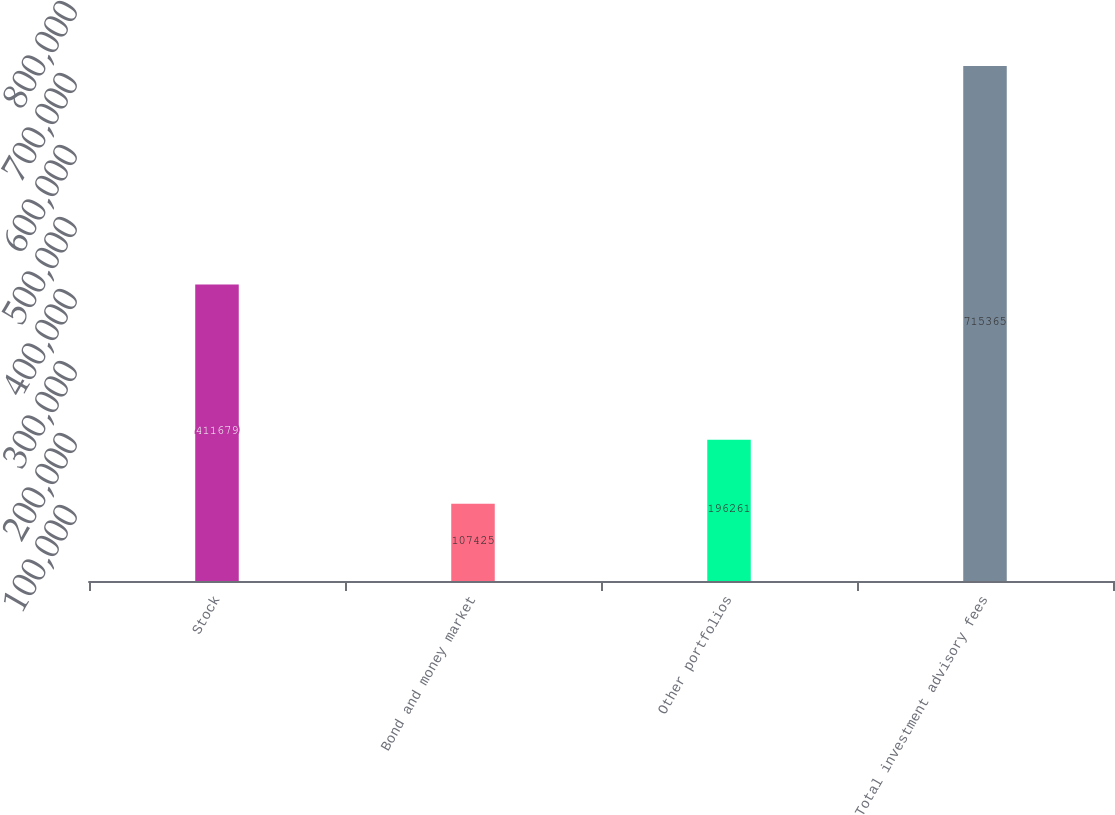Convert chart to OTSL. <chart><loc_0><loc_0><loc_500><loc_500><bar_chart><fcel>Stock<fcel>Bond and money market<fcel>Other portfolios<fcel>Total investment advisory fees<nl><fcel>411679<fcel>107425<fcel>196261<fcel>715365<nl></chart> 